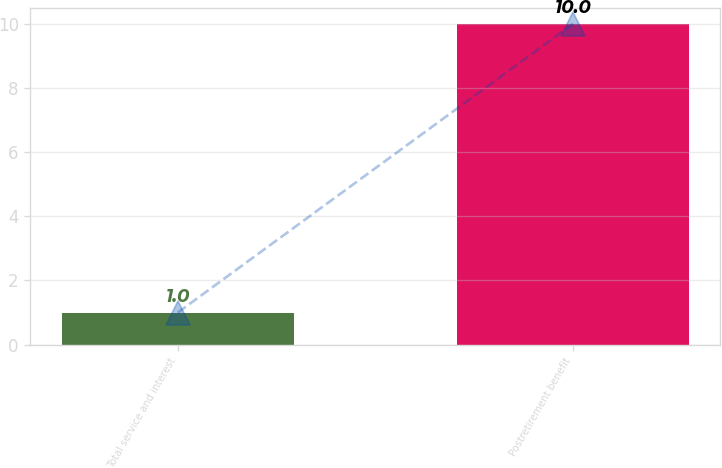Convert chart to OTSL. <chart><loc_0><loc_0><loc_500><loc_500><bar_chart><fcel>Total service and interest<fcel>Postretirement benefit<nl><fcel>1<fcel>10<nl></chart> 